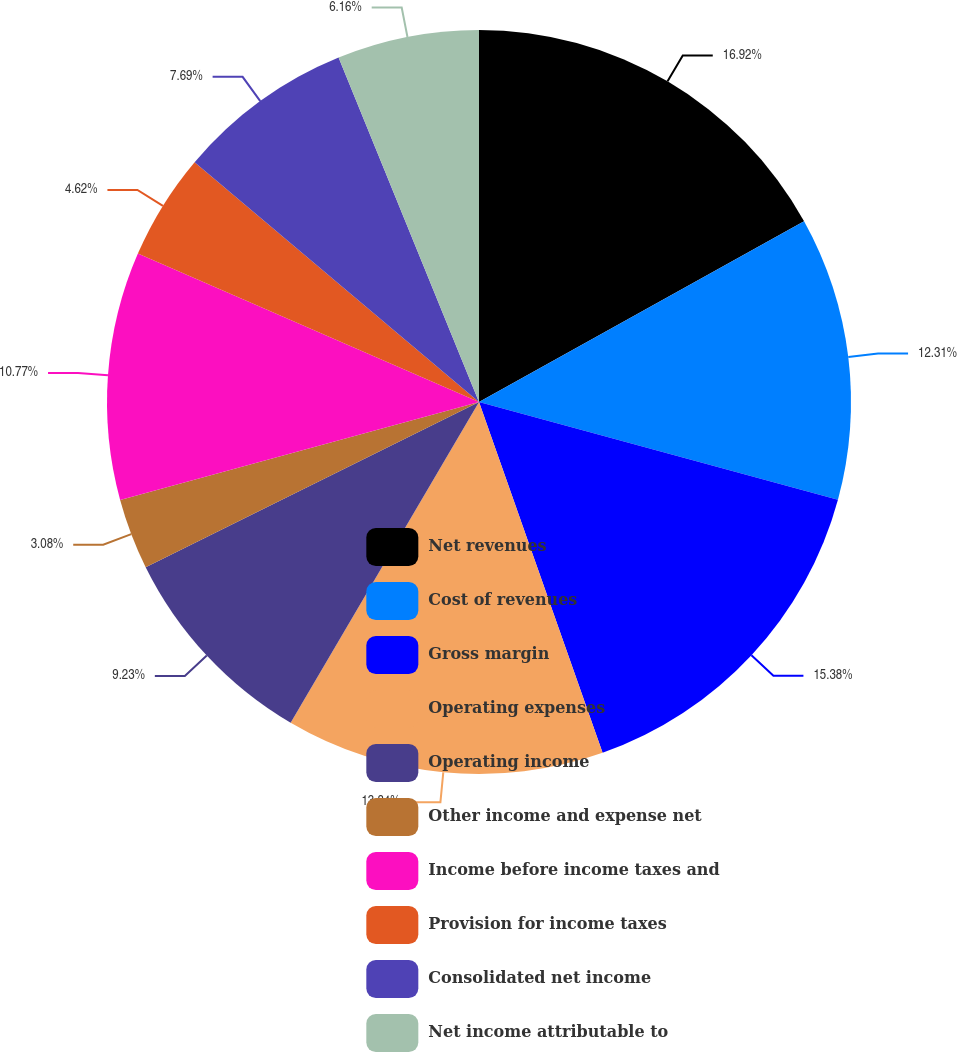<chart> <loc_0><loc_0><loc_500><loc_500><pie_chart><fcel>Net revenues<fcel>Cost of revenues<fcel>Gross margin<fcel>Operating expenses<fcel>Operating income<fcel>Other income and expense net<fcel>Income before income taxes and<fcel>Provision for income taxes<fcel>Consolidated net income<fcel>Net income attributable to<nl><fcel>16.92%<fcel>12.31%<fcel>15.38%<fcel>13.84%<fcel>9.23%<fcel>3.08%<fcel>10.77%<fcel>4.62%<fcel>7.69%<fcel>6.16%<nl></chart> 